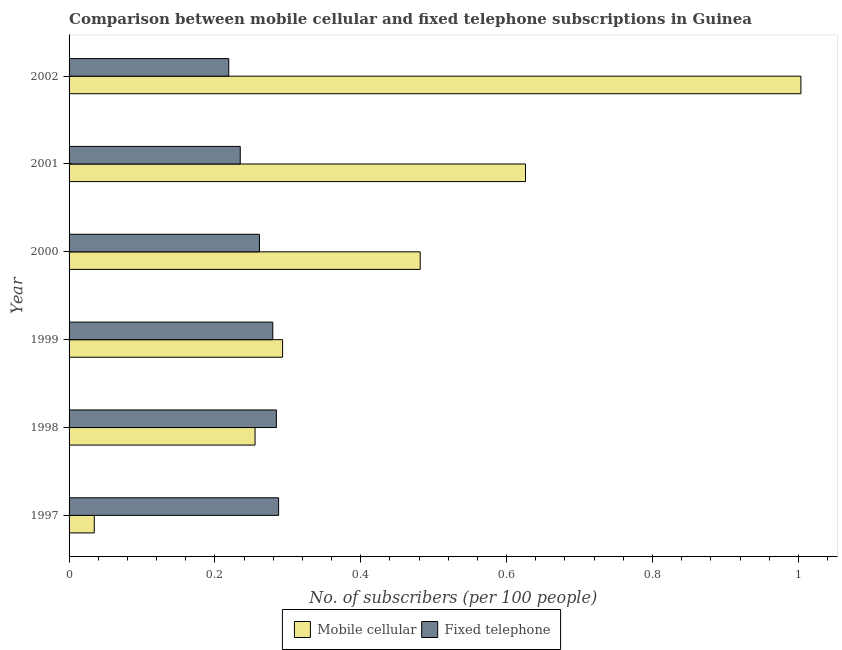How many different coloured bars are there?
Your answer should be compact. 2. How many groups of bars are there?
Offer a very short reply. 6. Are the number of bars per tick equal to the number of legend labels?
Give a very brief answer. Yes. What is the label of the 3rd group of bars from the top?
Your answer should be very brief. 2000. What is the number of fixed telephone subscribers in 1999?
Make the answer very short. 0.28. Across all years, what is the maximum number of mobile cellular subscribers?
Provide a succinct answer. 1. Across all years, what is the minimum number of fixed telephone subscribers?
Provide a succinct answer. 0.22. In which year was the number of mobile cellular subscribers maximum?
Provide a succinct answer. 2002. What is the total number of fixed telephone subscribers in the graph?
Ensure brevity in your answer.  1.57. What is the difference between the number of mobile cellular subscribers in 2001 and that in 2002?
Offer a terse response. -0.38. What is the difference between the number of fixed telephone subscribers in 1998 and the number of mobile cellular subscribers in 2001?
Offer a very short reply. -0.34. What is the average number of fixed telephone subscribers per year?
Your answer should be very brief. 0.26. In the year 1998, what is the difference between the number of fixed telephone subscribers and number of mobile cellular subscribers?
Provide a succinct answer. 0.03. What is the ratio of the number of fixed telephone subscribers in 2000 to that in 2001?
Make the answer very short. 1.11. Is the number of mobile cellular subscribers in 1997 less than that in 1998?
Your answer should be compact. Yes. What is the difference between the highest and the second highest number of fixed telephone subscribers?
Keep it short and to the point. 0. What is the difference between the highest and the lowest number of mobile cellular subscribers?
Offer a terse response. 0.97. In how many years, is the number of mobile cellular subscribers greater than the average number of mobile cellular subscribers taken over all years?
Your answer should be compact. 3. What does the 1st bar from the top in 2002 represents?
Provide a succinct answer. Fixed telephone. What does the 1st bar from the bottom in 2002 represents?
Keep it short and to the point. Mobile cellular. How many bars are there?
Your response must be concise. 12. How many years are there in the graph?
Keep it short and to the point. 6. Does the graph contain grids?
Provide a succinct answer. No. How many legend labels are there?
Ensure brevity in your answer.  2. How are the legend labels stacked?
Offer a very short reply. Horizontal. What is the title of the graph?
Provide a short and direct response. Comparison between mobile cellular and fixed telephone subscriptions in Guinea. What is the label or title of the X-axis?
Your answer should be very brief. No. of subscribers (per 100 people). What is the No. of subscribers (per 100 people) in Mobile cellular in 1997?
Offer a very short reply. 0.03. What is the No. of subscribers (per 100 people) of Fixed telephone in 1997?
Your response must be concise. 0.29. What is the No. of subscribers (per 100 people) of Mobile cellular in 1998?
Provide a short and direct response. 0.26. What is the No. of subscribers (per 100 people) of Fixed telephone in 1998?
Keep it short and to the point. 0.28. What is the No. of subscribers (per 100 people) in Mobile cellular in 1999?
Ensure brevity in your answer.  0.29. What is the No. of subscribers (per 100 people) in Fixed telephone in 1999?
Your answer should be very brief. 0.28. What is the No. of subscribers (per 100 people) in Mobile cellular in 2000?
Provide a succinct answer. 0.48. What is the No. of subscribers (per 100 people) of Fixed telephone in 2000?
Provide a short and direct response. 0.26. What is the No. of subscribers (per 100 people) in Mobile cellular in 2001?
Provide a short and direct response. 0.63. What is the No. of subscribers (per 100 people) in Fixed telephone in 2001?
Your response must be concise. 0.23. What is the No. of subscribers (per 100 people) in Mobile cellular in 2002?
Make the answer very short. 1. What is the No. of subscribers (per 100 people) of Fixed telephone in 2002?
Ensure brevity in your answer.  0.22. Across all years, what is the maximum No. of subscribers (per 100 people) in Mobile cellular?
Make the answer very short. 1. Across all years, what is the maximum No. of subscribers (per 100 people) in Fixed telephone?
Keep it short and to the point. 0.29. Across all years, what is the minimum No. of subscribers (per 100 people) of Mobile cellular?
Keep it short and to the point. 0.03. Across all years, what is the minimum No. of subscribers (per 100 people) in Fixed telephone?
Provide a short and direct response. 0.22. What is the total No. of subscribers (per 100 people) in Mobile cellular in the graph?
Your answer should be compact. 2.69. What is the total No. of subscribers (per 100 people) of Fixed telephone in the graph?
Offer a very short reply. 1.57. What is the difference between the No. of subscribers (per 100 people) of Mobile cellular in 1997 and that in 1998?
Offer a terse response. -0.22. What is the difference between the No. of subscribers (per 100 people) of Fixed telephone in 1997 and that in 1998?
Provide a short and direct response. 0. What is the difference between the No. of subscribers (per 100 people) of Mobile cellular in 1997 and that in 1999?
Make the answer very short. -0.26. What is the difference between the No. of subscribers (per 100 people) of Fixed telephone in 1997 and that in 1999?
Keep it short and to the point. 0.01. What is the difference between the No. of subscribers (per 100 people) of Mobile cellular in 1997 and that in 2000?
Offer a terse response. -0.45. What is the difference between the No. of subscribers (per 100 people) of Fixed telephone in 1997 and that in 2000?
Your answer should be compact. 0.03. What is the difference between the No. of subscribers (per 100 people) of Mobile cellular in 1997 and that in 2001?
Give a very brief answer. -0.59. What is the difference between the No. of subscribers (per 100 people) in Fixed telephone in 1997 and that in 2001?
Offer a terse response. 0.05. What is the difference between the No. of subscribers (per 100 people) in Mobile cellular in 1997 and that in 2002?
Make the answer very short. -0.97. What is the difference between the No. of subscribers (per 100 people) in Fixed telephone in 1997 and that in 2002?
Your answer should be compact. 0.07. What is the difference between the No. of subscribers (per 100 people) of Mobile cellular in 1998 and that in 1999?
Offer a very short reply. -0.04. What is the difference between the No. of subscribers (per 100 people) of Fixed telephone in 1998 and that in 1999?
Your answer should be compact. 0. What is the difference between the No. of subscribers (per 100 people) of Mobile cellular in 1998 and that in 2000?
Make the answer very short. -0.23. What is the difference between the No. of subscribers (per 100 people) in Fixed telephone in 1998 and that in 2000?
Offer a terse response. 0.02. What is the difference between the No. of subscribers (per 100 people) of Mobile cellular in 1998 and that in 2001?
Provide a succinct answer. -0.37. What is the difference between the No. of subscribers (per 100 people) of Fixed telephone in 1998 and that in 2001?
Give a very brief answer. 0.05. What is the difference between the No. of subscribers (per 100 people) of Mobile cellular in 1998 and that in 2002?
Your answer should be very brief. -0.75. What is the difference between the No. of subscribers (per 100 people) in Fixed telephone in 1998 and that in 2002?
Provide a short and direct response. 0.07. What is the difference between the No. of subscribers (per 100 people) of Mobile cellular in 1999 and that in 2000?
Your response must be concise. -0.19. What is the difference between the No. of subscribers (per 100 people) in Fixed telephone in 1999 and that in 2000?
Offer a terse response. 0.02. What is the difference between the No. of subscribers (per 100 people) in Mobile cellular in 1999 and that in 2001?
Your answer should be compact. -0.33. What is the difference between the No. of subscribers (per 100 people) in Fixed telephone in 1999 and that in 2001?
Give a very brief answer. 0.04. What is the difference between the No. of subscribers (per 100 people) of Mobile cellular in 1999 and that in 2002?
Provide a short and direct response. -0.71. What is the difference between the No. of subscribers (per 100 people) in Fixed telephone in 1999 and that in 2002?
Make the answer very short. 0.06. What is the difference between the No. of subscribers (per 100 people) of Mobile cellular in 2000 and that in 2001?
Your response must be concise. -0.14. What is the difference between the No. of subscribers (per 100 people) of Fixed telephone in 2000 and that in 2001?
Offer a very short reply. 0.03. What is the difference between the No. of subscribers (per 100 people) of Mobile cellular in 2000 and that in 2002?
Provide a succinct answer. -0.52. What is the difference between the No. of subscribers (per 100 people) in Fixed telephone in 2000 and that in 2002?
Your answer should be compact. 0.04. What is the difference between the No. of subscribers (per 100 people) in Mobile cellular in 2001 and that in 2002?
Your answer should be compact. -0.38. What is the difference between the No. of subscribers (per 100 people) in Fixed telephone in 2001 and that in 2002?
Your answer should be compact. 0.02. What is the difference between the No. of subscribers (per 100 people) in Mobile cellular in 1997 and the No. of subscribers (per 100 people) in Fixed telephone in 1998?
Provide a short and direct response. -0.25. What is the difference between the No. of subscribers (per 100 people) in Mobile cellular in 1997 and the No. of subscribers (per 100 people) in Fixed telephone in 1999?
Ensure brevity in your answer.  -0.24. What is the difference between the No. of subscribers (per 100 people) of Mobile cellular in 1997 and the No. of subscribers (per 100 people) of Fixed telephone in 2000?
Make the answer very short. -0.23. What is the difference between the No. of subscribers (per 100 people) in Mobile cellular in 1997 and the No. of subscribers (per 100 people) in Fixed telephone in 2001?
Your answer should be very brief. -0.2. What is the difference between the No. of subscribers (per 100 people) in Mobile cellular in 1997 and the No. of subscribers (per 100 people) in Fixed telephone in 2002?
Offer a very short reply. -0.18. What is the difference between the No. of subscribers (per 100 people) of Mobile cellular in 1998 and the No. of subscribers (per 100 people) of Fixed telephone in 1999?
Give a very brief answer. -0.02. What is the difference between the No. of subscribers (per 100 people) of Mobile cellular in 1998 and the No. of subscribers (per 100 people) of Fixed telephone in 2000?
Keep it short and to the point. -0.01. What is the difference between the No. of subscribers (per 100 people) in Mobile cellular in 1998 and the No. of subscribers (per 100 people) in Fixed telephone in 2001?
Ensure brevity in your answer.  0.02. What is the difference between the No. of subscribers (per 100 people) in Mobile cellular in 1998 and the No. of subscribers (per 100 people) in Fixed telephone in 2002?
Your answer should be compact. 0.04. What is the difference between the No. of subscribers (per 100 people) in Mobile cellular in 1999 and the No. of subscribers (per 100 people) in Fixed telephone in 2000?
Your answer should be compact. 0.03. What is the difference between the No. of subscribers (per 100 people) of Mobile cellular in 1999 and the No. of subscribers (per 100 people) of Fixed telephone in 2001?
Make the answer very short. 0.06. What is the difference between the No. of subscribers (per 100 people) in Mobile cellular in 1999 and the No. of subscribers (per 100 people) in Fixed telephone in 2002?
Offer a very short reply. 0.07. What is the difference between the No. of subscribers (per 100 people) in Mobile cellular in 2000 and the No. of subscribers (per 100 people) in Fixed telephone in 2001?
Give a very brief answer. 0.25. What is the difference between the No. of subscribers (per 100 people) of Mobile cellular in 2000 and the No. of subscribers (per 100 people) of Fixed telephone in 2002?
Make the answer very short. 0.26. What is the difference between the No. of subscribers (per 100 people) of Mobile cellular in 2001 and the No. of subscribers (per 100 people) of Fixed telephone in 2002?
Provide a short and direct response. 0.41. What is the average No. of subscribers (per 100 people) of Mobile cellular per year?
Offer a terse response. 0.45. What is the average No. of subscribers (per 100 people) of Fixed telephone per year?
Provide a short and direct response. 0.26. In the year 1997, what is the difference between the No. of subscribers (per 100 people) in Mobile cellular and No. of subscribers (per 100 people) in Fixed telephone?
Provide a succinct answer. -0.25. In the year 1998, what is the difference between the No. of subscribers (per 100 people) of Mobile cellular and No. of subscribers (per 100 people) of Fixed telephone?
Provide a short and direct response. -0.03. In the year 1999, what is the difference between the No. of subscribers (per 100 people) of Mobile cellular and No. of subscribers (per 100 people) of Fixed telephone?
Provide a succinct answer. 0.01. In the year 2000, what is the difference between the No. of subscribers (per 100 people) of Mobile cellular and No. of subscribers (per 100 people) of Fixed telephone?
Keep it short and to the point. 0.22. In the year 2001, what is the difference between the No. of subscribers (per 100 people) of Mobile cellular and No. of subscribers (per 100 people) of Fixed telephone?
Your response must be concise. 0.39. In the year 2002, what is the difference between the No. of subscribers (per 100 people) in Mobile cellular and No. of subscribers (per 100 people) in Fixed telephone?
Your response must be concise. 0.78. What is the ratio of the No. of subscribers (per 100 people) of Mobile cellular in 1997 to that in 1998?
Provide a short and direct response. 0.14. What is the ratio of the No. of subscribers (per 100 people) in Fixed telephone in 1997 to that in 1998?
Your answer should be very brief. 1.01. What is the ratio of the No. of subscribers (per 100 people) in Mobile cellular in 1997 to that in 1999?
Make the answer very short. 0.12. What is the ratio of the No. of subscribers (per 100 people) of Fixed telephone in 1997 to that in 1999?
Provide a succinct answer. 1.03. What is the ratio of the No. of subscribers (per 100 people) in Mobile cellular in 1997 to that in 2000?
Your answer should be very brief. 0.07. What is the ratio of the No. of subscribers (per 100 people) of Fixed telephone in 1997 to that in 2000?
Offer a very short reply. 1.1. What is the ratio of the No. of subscribers (per 100 people) in Mobile cellular in 1997 to that in 2001?
Make the answer very short. 0.06. What is the ratio of the No. of subscribers (per 100 people) in Fixed telephone in 1997 to that in 2001?
Provide a short and direct response. 1.22. What is the ratio of the No. of subscribers (per 100 people) in Mobile cellular in 1997 to that in 2002?
Give a very brief answer. 0.03. What is the ratio of the No. of subscribers (per 100 people) in Fixed telephone in 1997 to that in 2002?
Give a very brief answer. 1.31. What is the ratio of the No. of subscribers (per 100 people) of Mobile cellular in 1998 to that in 1999?
Keep it short and to the point. 0.87. What is the ratio of the No. of subscribers (per 100 people) of Fixed telephone in 1998 to that in 1999?
Your response must be concise. 1.02. What is the ratio of the No. of subscribers (per 100 people) of Mobile cellular in 1998 to that in 2000?
Offer a very short reply. 0.53. What is the ratio of the No. of subscribers (per 100 people) in Fixed telephone in 1998 to that in 2000?
Keep it short and to the point. 1.09. What is the ratio of the No. of subscribers (per 100 people) in Mobile cellular in 1998 to that in 2001?
Your answer should be very brief. 0.41. What is the ratio of the No. of subscribers (per 100 people) in Fixed telephone in 1998 to that in 2001?
Your answer should be very brief. 1.21. What is the ratio of the No. of subscribers (per 100 people) of Mobile cellular in 1998 to that in 2002?
Offer a very short reply. 0.25. What is the ratio of the No. of subscribers (per 100 people) of Fixed telephone in 1998 to that in 2002?
Make the answer very short. 1.3. What is the ratio of the No. of subscribers (per 100 people) of Mobile cellular in 1999 to that in 2000?
Provide a short and direct response. 0.61. What is the ratio of the No. of subscribers (per 100 people) in Fixed telephone in 1999 to that in 2000?
Make the answer very short. 1.07. What is the ratio of the No. of subscribers (per 100 people) of Mobile cellular in 1999 to that in 2001?
Keep it short and to the point. 0.47. What is the ratio of the No. of subscribers (per 100 people) in Fixed telephone in 1999 to that in 2001?
Your answer should be compact. 1.19. What is the ratio of the No. of subscribers (per 100 people) in Mobile cellular in 1999 to that in 2002?
Your answer should be compact. 0.29. What is the ratio of the No. of subscribers (per 100 people) of Fixed telephone in 1999 to that in 2002?
Keep it short and to the point. 1.28. What is the ratio of the No. of subscribers (per 100 people) of Mobile cellular in 2000 to that in 2001?
Provide a short and direct response. 0.77. What is the ratio of the No. of subscribers (per 100 people) in Fixed telephone in 2000 to that in 2001?
Provide a short and direct response. 1.11. What is the ratio of the No. of subscribers (per 100 people) of Mobile cellular in 2000 to that in 2002?
Your answer should be compact. 0.48. What is the ratio of the No. of subscribers (per 100 people) of Fixed telephone in 2000 to that in 2002?
Provide a short and direct response. 1.19. What is the ratio of the No. of subscribers (per 100 people) of Mobile cellular in 2001 to that in 2002?
Provide a succinct answer. 0.62. What is the ratio of the No. of subscribers (per 100 people) in Fixed telephone in 2001 to that in 2002?
Offer a very short reply. 1.07. What is the difference between the highest and the second highest No. of subscribers (per 100 people) in Mobile cellular?
Your answer should be very brief. 0.38. What is the difference between the highest and the second highest No. of subscribers (per 100 people) in Fixed telephone?
Make the answer very short. 0. What is the difference between the highest and the lowest No. of subscribers (per 100 people) in Mobile cellular?
Keep it short and to the point. 0.97. What is the difference between the highest and the lowest No. of subscribers (per 100 people) in Fixed telephone?
Make the answer very short. 0.07. 